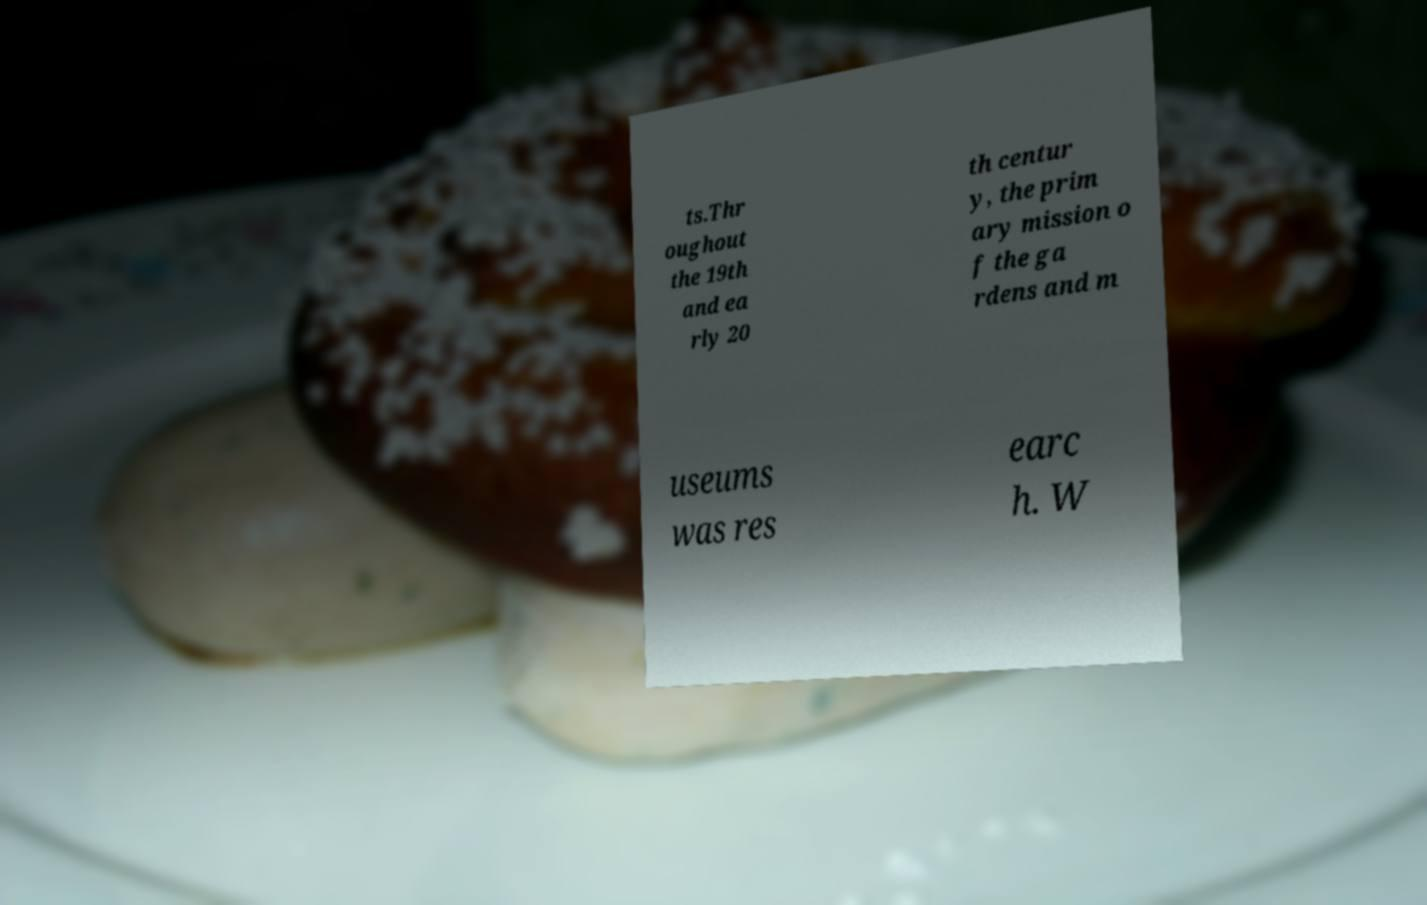For documentation purposes, I need the text within this image transcribed. Could you provide that? ts.Thr oughout the 19th and ea rly 20 th centur y, the prim ary mission o f the ga rdens and m useums was res earc h. W 